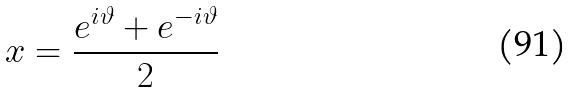<formula> <loc_0><loc_0><loc_500><loc_500>x = \frac { e ^ { i \vartheta } + e ^ { - i \vartheta } } { 2 }</formula> 